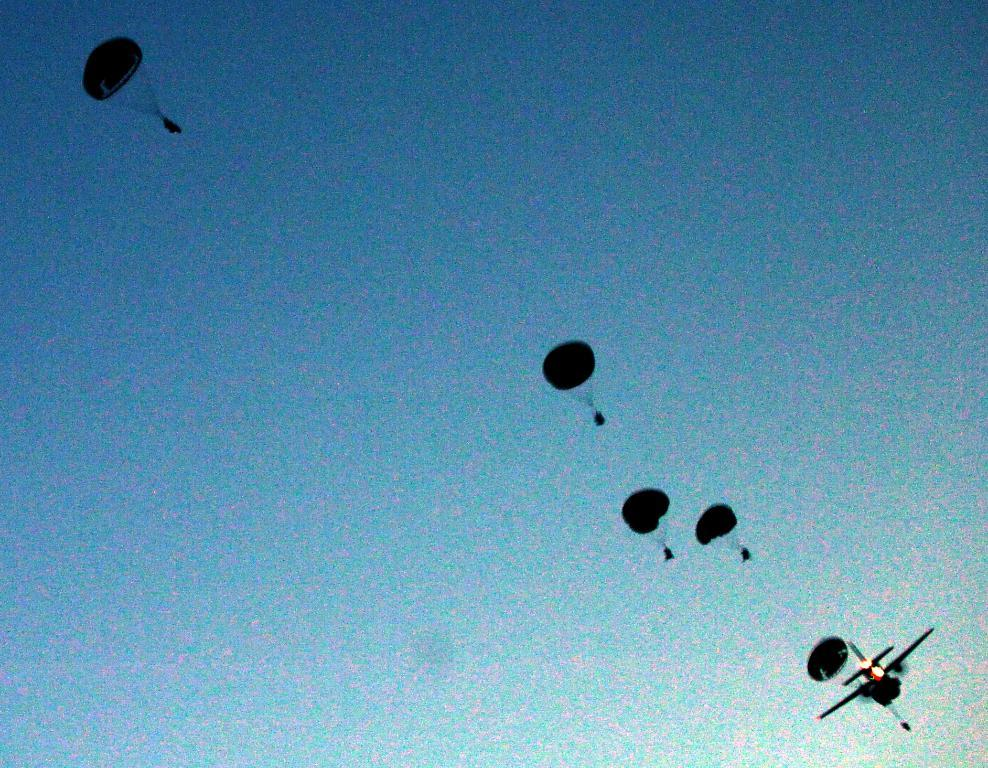What objects are visible in the image related to skydiving or aerial activities? There are parachutes in the image. What can be seen in the sky in the image? There is an airplane flying in the sky in the image. What type of skin condition is visible on the parachutes in the image? There is no skin condition present on the parachutes in the image, as parachutes are not living organisms and do not have skin. 